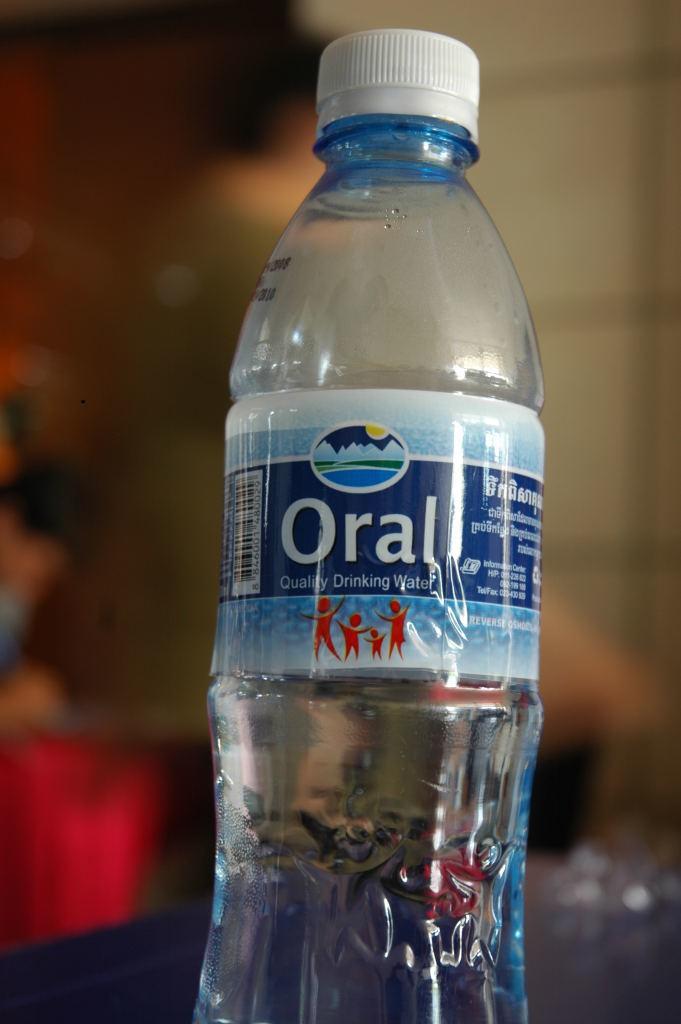Can you describe this image briefly? In this picture this is a water bottle and the bottle is covered with a sticker and the cap is in white color. Behind the bottle is blue. 